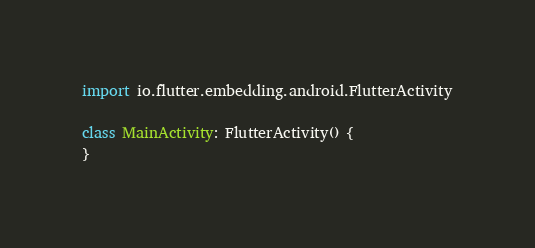<code> <loc_0><loc_0><loc_500><loc_500><_Kotlin_>
import io.flutter.embedding.android.FlutterActivity

class MainActivity: FlutterActivity() {
}
</code> 